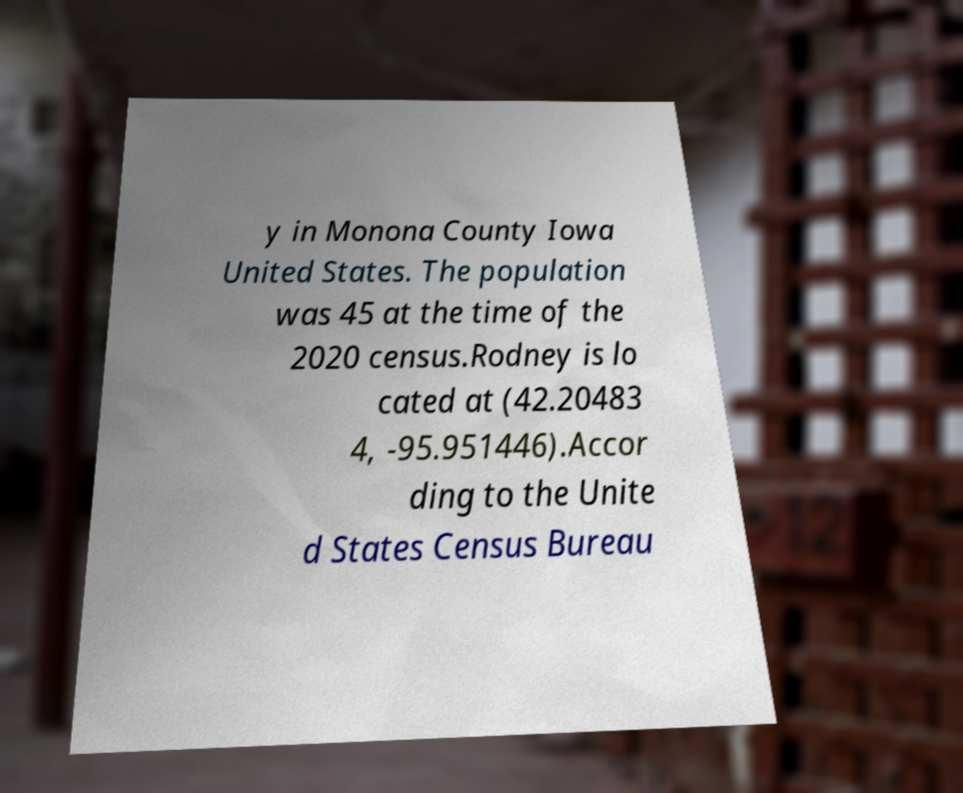Please read and relay the text visible in this image. What does it say? y in Monona County Iowa United States. The population was 45 at the time of the 2020 census.Rodney is lo cated at (42.20483 4, -95.951446).Accor ding to the Unite d States Census Bureau 